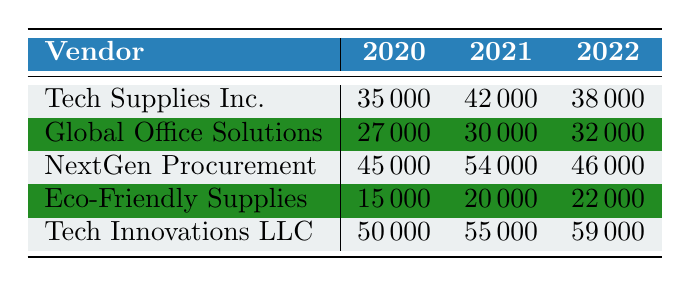What was the procurement cost for Tech Supplies Inc. in 2021? The table shows that the cost for Tech Supplies Inc. in the year 2021 is listed directly under the 2021 column. The value is 42000.
Answer: 42000 Which vendor had the highest procurement cost in 2022? By checking the costs in the 2022 column across all vendors, the costs are Tech Supplies Inc. (38000), Global Office Solutions (32000), NextGen Procurement (46000), Eco-Friendly Supplies (22000), and Tech Innovations LLC (59000). Tech Innovations LLC has the highest cost at 59000.
Answer: Tech Innovations LLC What is the total procurement cost for Global Office Solutions over the three years? First, we find the costs for Global Office Solutions from the table: 2020 (27000), 2021 (30000), and 2022 (32000). To find the total, we add these values: 27000 + 30000 + 32000 = 89000.
Answer: 89000 Did any vendor have a decreasing trend in procurement costs from 2020 to 2022? Analyzing the costs for each vendor: Tech Supplies Inc. (35000 to 38000), Global Office Solutions (27000 to 32000), NextGen Procurement (45000 to 46000), Eco-Friendly Supplies (15000 to 22000), and Tech Innovations LLC (50000 to 59000). None of the vendors exhibited a decreasing trend over this period; all costs either increased or remained stable.
Answer: No What is the average procurement cost for NextGen Procurement over the three years? For NextGen Procurement, the costs are: 2020 (45000), 2021 (54000), and 2022 (46000). The total cost is 45000 + 54000 + 46000 = 145000. Then, we divide this total by 3 to find the average: 145000 / 3 = 48333.33. Rounded, this is approximately 48333.
Answer: 48333.33 